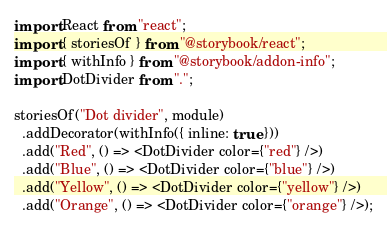Convert code to text. <code><loc_0><loc_0><loc_500><loc_500><_TypeScript_>import React from "react";
import { storiesOf } from "@storybook/react";
import { withInfo } from "@storybook/addon-info";
import DotDivider from ".";

storiesOf("Dot divider", module)
  .addDecorator(withInfo({ inline: true }))
  .add("Red", () => <DotDivider color={"red"} />)
  .add("Blue", () => <DotDivider color={"blue"} />)
  .add("Yellow", () => <DotDivider color={"yellow"} />)
  .add("Orange", () => <DotDivider color={"orange"} />);
</code> 